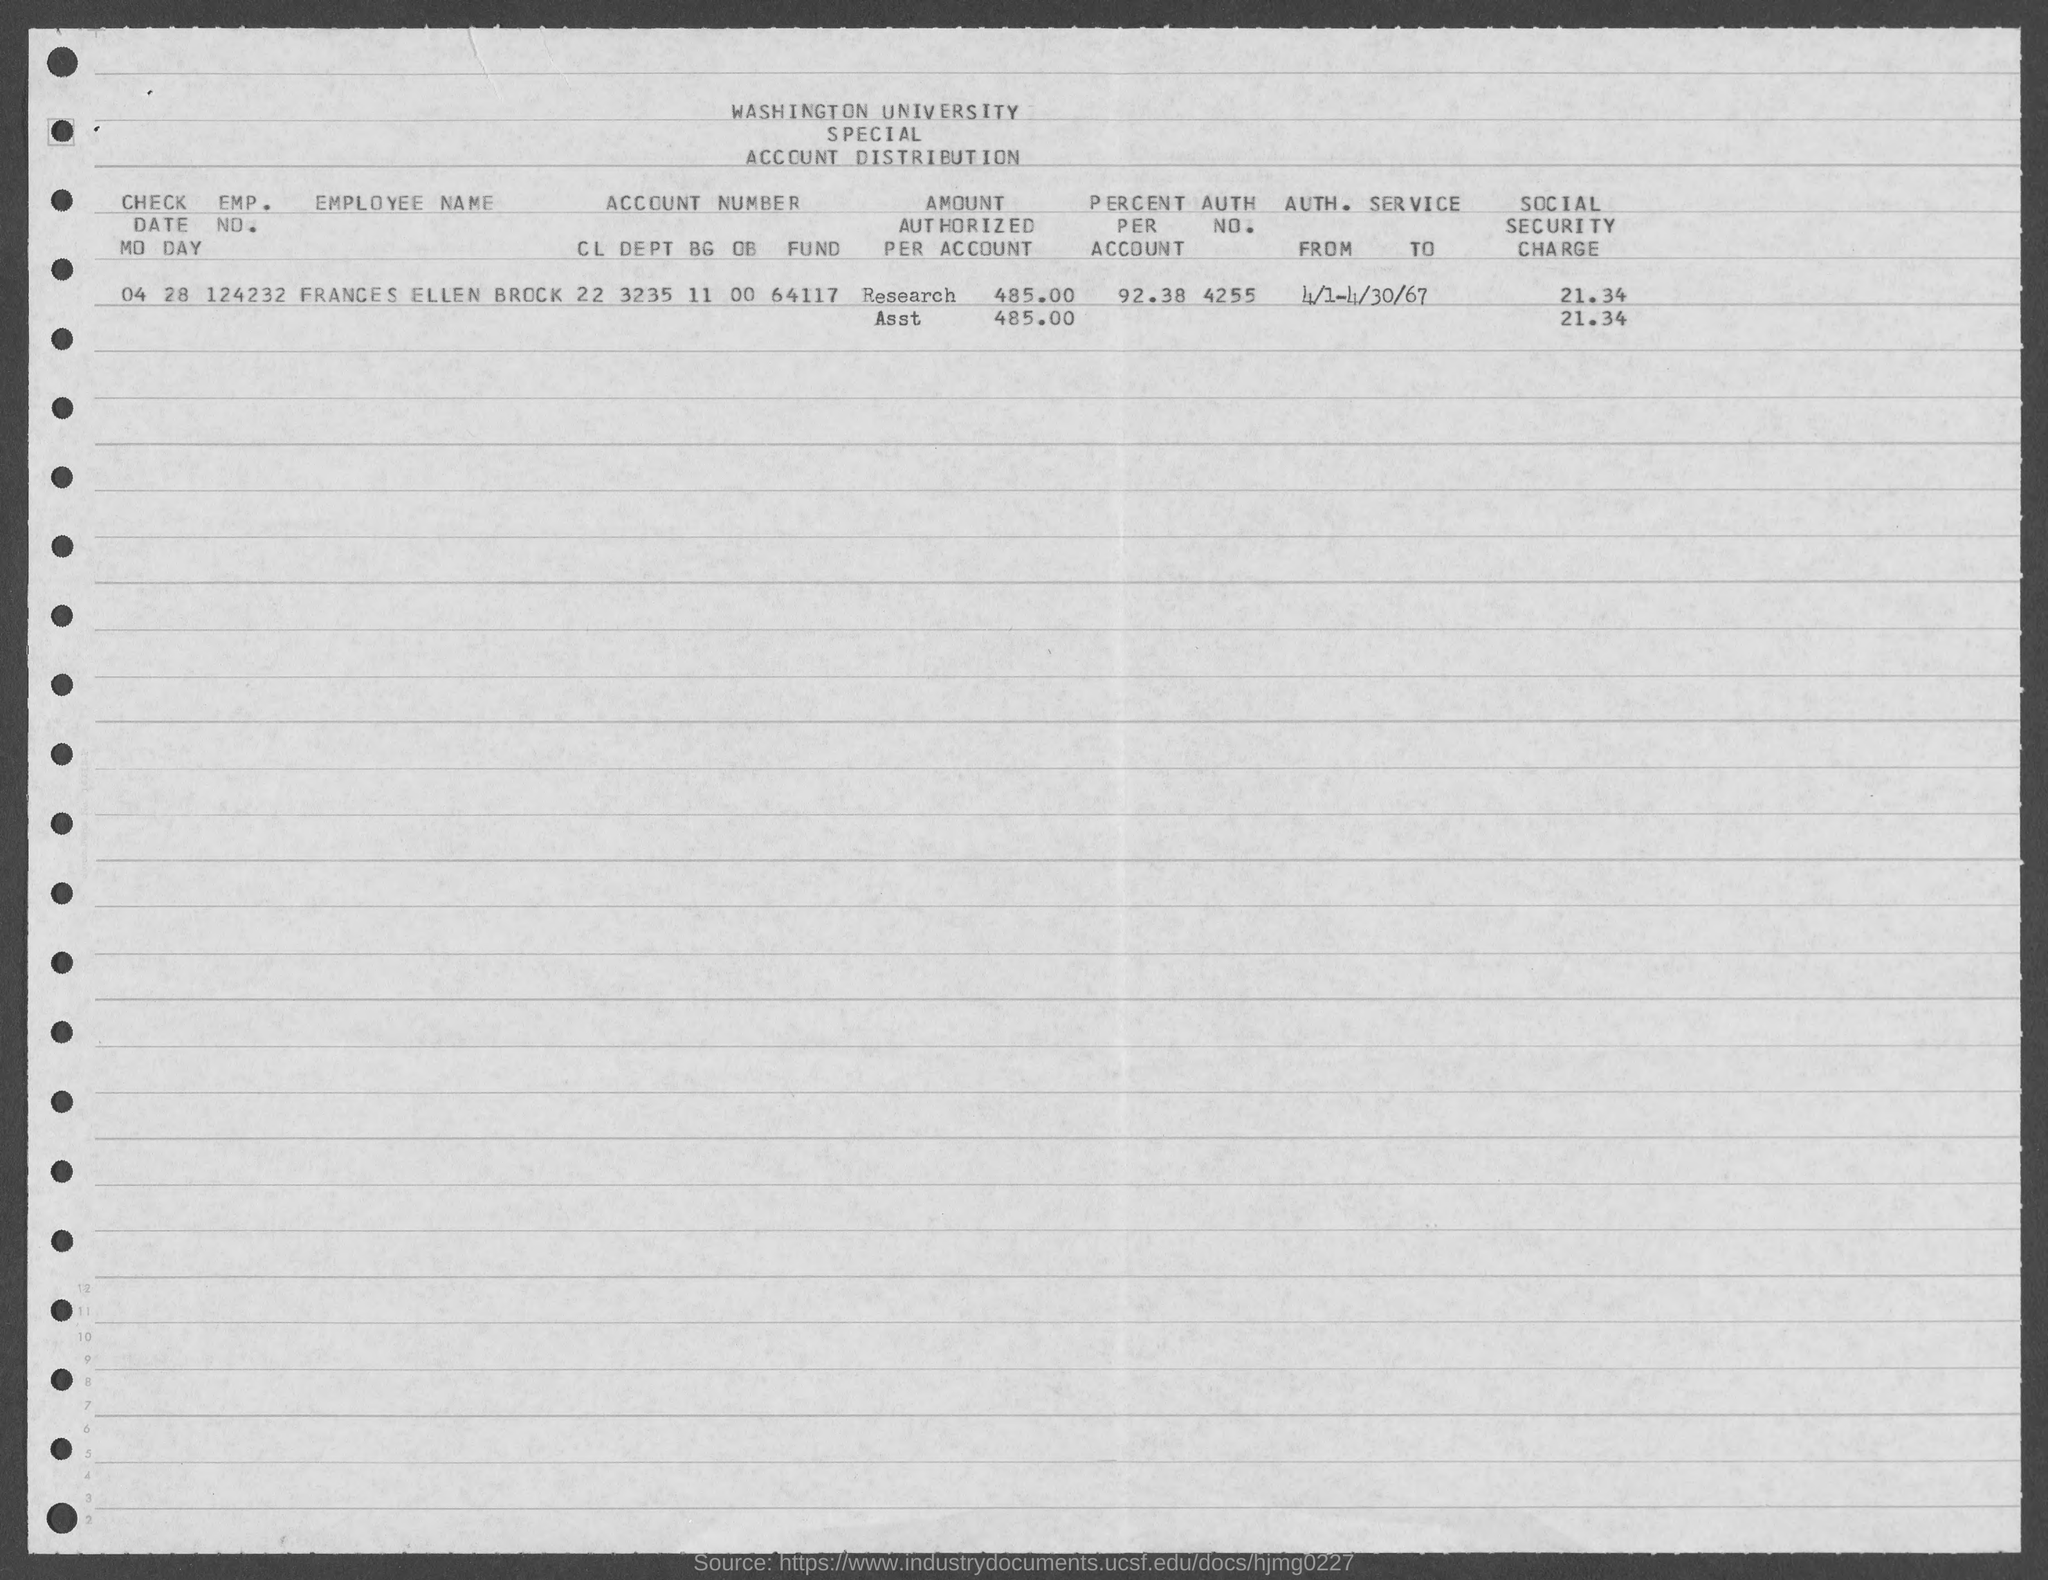What is the emp. no. of frances ellen brock as mentioned in the given form ?
Offer a terse response. 124232. What is the check date mentioned in the given form ?
Your response must be concise. 04-28. What is the auth. no. mentioned in the given form ?
Provide a short and direct response. 4255. What is the value of percent per account as mentioned in the given form ?
Ensure brevity in your answer.  92.38. What is the value of social security charge mentioned in the given page ?
Offer a terse response. 21.34. 